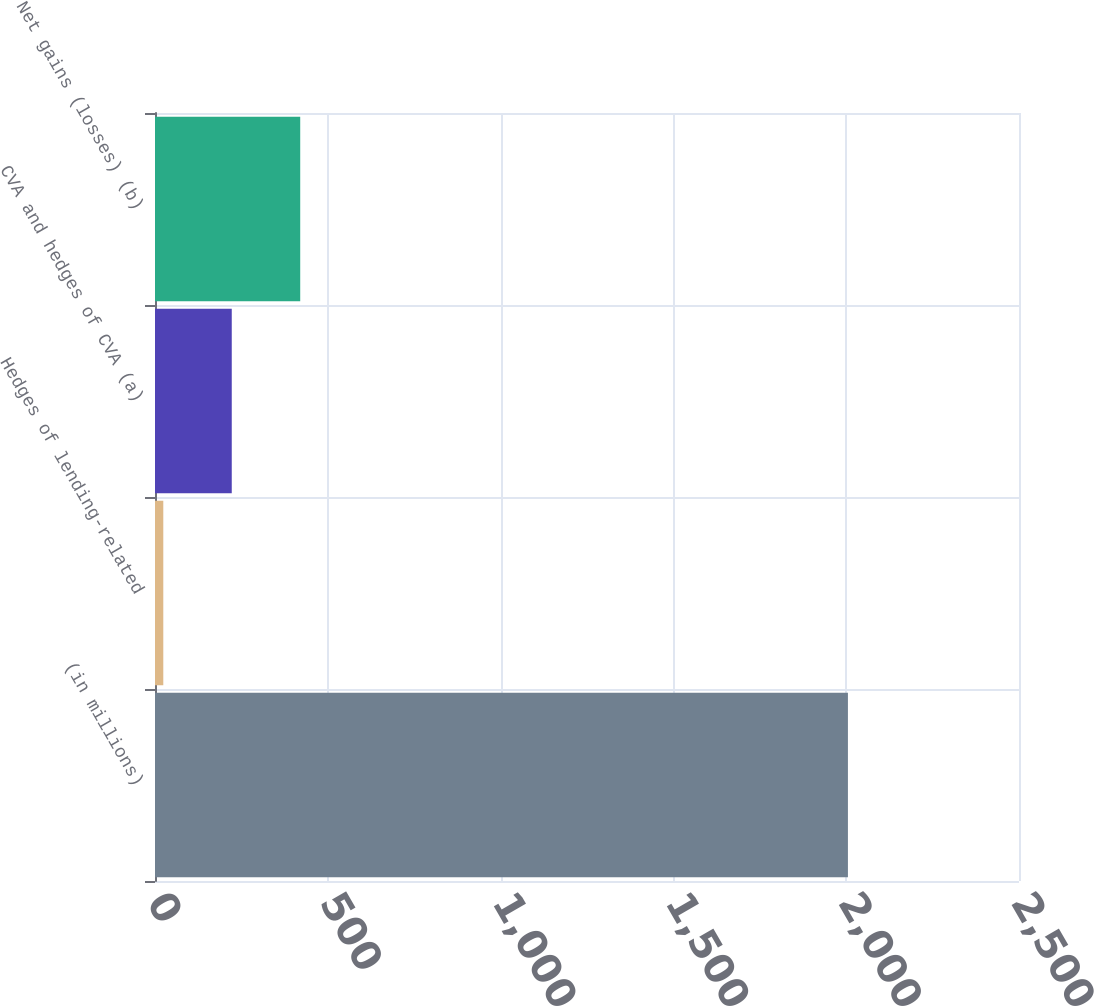<chart> <loc_0><loc_0><loc_500><loc_500><bar_chart><fcel>(in millions)<fcel>Hedges of lending-related<fcel>CVA and hedges of CVA (a)<fcel>Net gains (losses) (b)<nl><fcel>2005<fcel>24<fcel>222.1<fcel>420.2<nl></chart> 